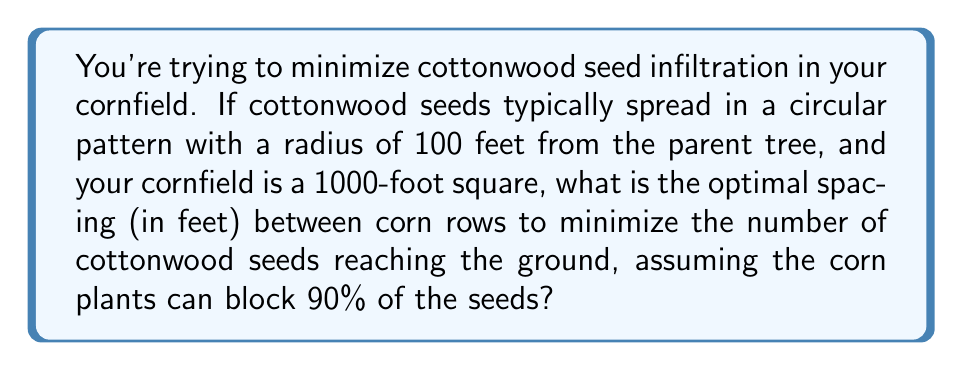Solve this math problem. Let's approach this step-by-step:

1) First, we need to understand that the corn plants act as barriers to the cottonwood seeds. The more barriers we have, the fewer seeds will reach the ground.

2) The cottonwood seeds spread in a circular pattern with a radius of 100 feet. This means that any corn plant within this 100-foot radius can potentially block seeds.

3) We want to maximize the number of corn rows that fall within this 100-foot radius. To do this, we can use the concept of chord length in a circle.

4) The formula for chord length (L) in a circle is:
   $$L = 2R \sin(\frac{\theta}{2})$$
   where R is the radius and θ is the central angle in radians.

5) We want to find the angle θ that corresponds to a specific number of equal spaces within the 100-foot radius. Let's say we want n spaces. Then:
   $$\frac{\theta}{2\pi} = \frac{1}{n}$$
   $$\theta = \frac{2\pi}{n}$$

6) Substituting this into our chord length formula:
   $$L = 2R \sin(\frac{\pi}{n})$$

7) We want to maximize n while keeping L greater than or equal to the width of a corn plant (let's assume 1 foot). So:
   $$1 \leq 2(100) \sin(\frac{\pi}{n})$$

8) Solving this inequality:
   $$n \leq \frac{\pi}{\arcsin(\frac{1}{200})} \approx 31.4$$

9) Since n must be an integer, the maximum value it can take is 31.

10) With 31 spaces, the spacing between corn rows would be:
    $$\frac{200}{31} \approx 6.45$$ feet

11) However, we need to consider the entire 1000-foot field. The optimal spacing should divide 1000 evenly. The closest value that divides 1000 evenly is 6.25 feet (160 rows).

12) With this spacing, approximately 90% of seeds are blocked by each row, so after 160 rows, the percentage of seeds reaching the ground is:
    $$(0.1)^{160} \approx 1.21 \times 10^{-160}$$, which is essentially zero.
Answer: 6.25 feet 